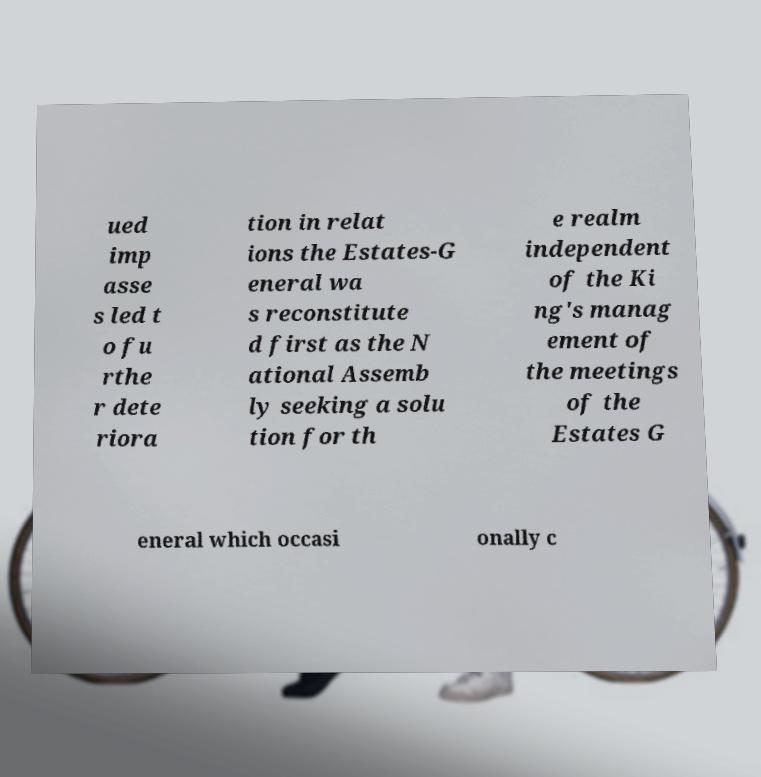Could you extract and type out the text from this image? ued imp asse s led t o fu rthe r dete riora tion in relat ions the Estates-G eneral wa s reconstitute d first as the N ational Assemb ly seeking a solu tion for th e realm independent of the Ki ng's manag ement of the meetings of the Estates G eneral which occasi onally c 